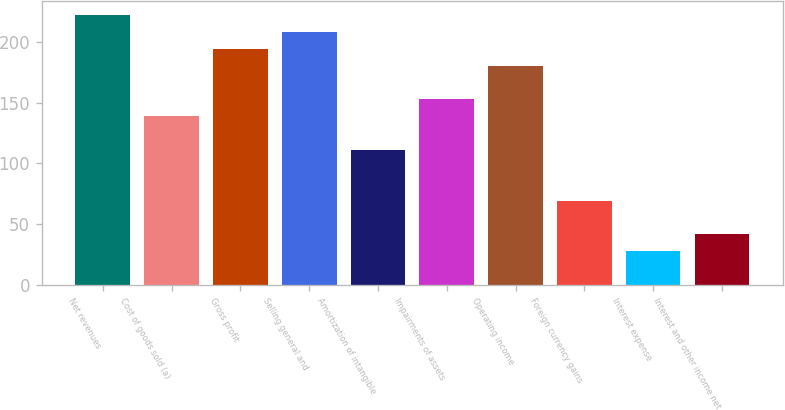Convert chart to OTSL. <chart><loc_0><loc_0><loc_500><loc_500><bar_chart><fcel>Net revenues<fcel>Cost of goods sold (a)<fcel>Gross profit<fcel>Selling general and<fcel>Amortization of intangible<fcel>Impairments of assets<fcel>Operating income<fcel>Foreign currency gains<fcel>Interest expense<fcel>Interest and other income net<nl><fcel>222.09<fcel>138.81<fcel>194.33<fcel>208.21<fcel>111.05<fcel>152.69<fcel>180.45<fcel>69.41<fcel>27.77<fcel>41.65<nl></chart> 